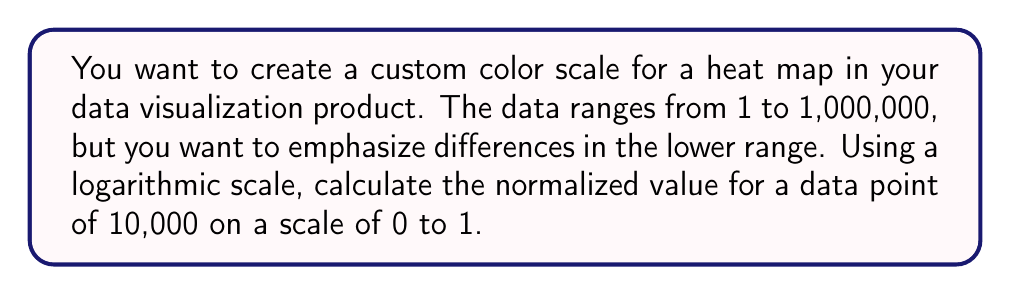Help me with this question. To create a logarithmic scale that emphasizes differences in the lower range, we'll use the following steps:

1. Define the range of our data:
   Minimum value: $min = 1$
   Maximum value: $max = 1,000,000$

2. Use the logarithm (base 10) to compress the scale:
   $$f(x) = \log_{10}(x)$$

3. Calculate the logarithm of the minimum, maximum, and our data point:
   $$\log_{10}(min) = \log_{10}(1) = 0$$
   $$\log_{10}(max) = \log_{10}(1,000,000) = 6$$
   $$\log_{10}(10,000) = 4$$

4. Normalize the logarithmic value to a scale of 0 to 1 using this formula:
   $$normalized\_value = \frac{\log_{10}(x) - \log_{10}(min)}{\log_{10}(max) - \log_{10}(min)}$$

5. Plug in our values:
   $$normalized\_value = \frac{4 - 0}{6 - 0} = \frac{4}{6} = \frac{2}{3}$$

Thus, the normalized value for 10,000 on our logarithmic scale from 0 to 1 is $\frac{2}{3}$ or approximately 0.6667.
Answer: $\frac{2}{3}$ 